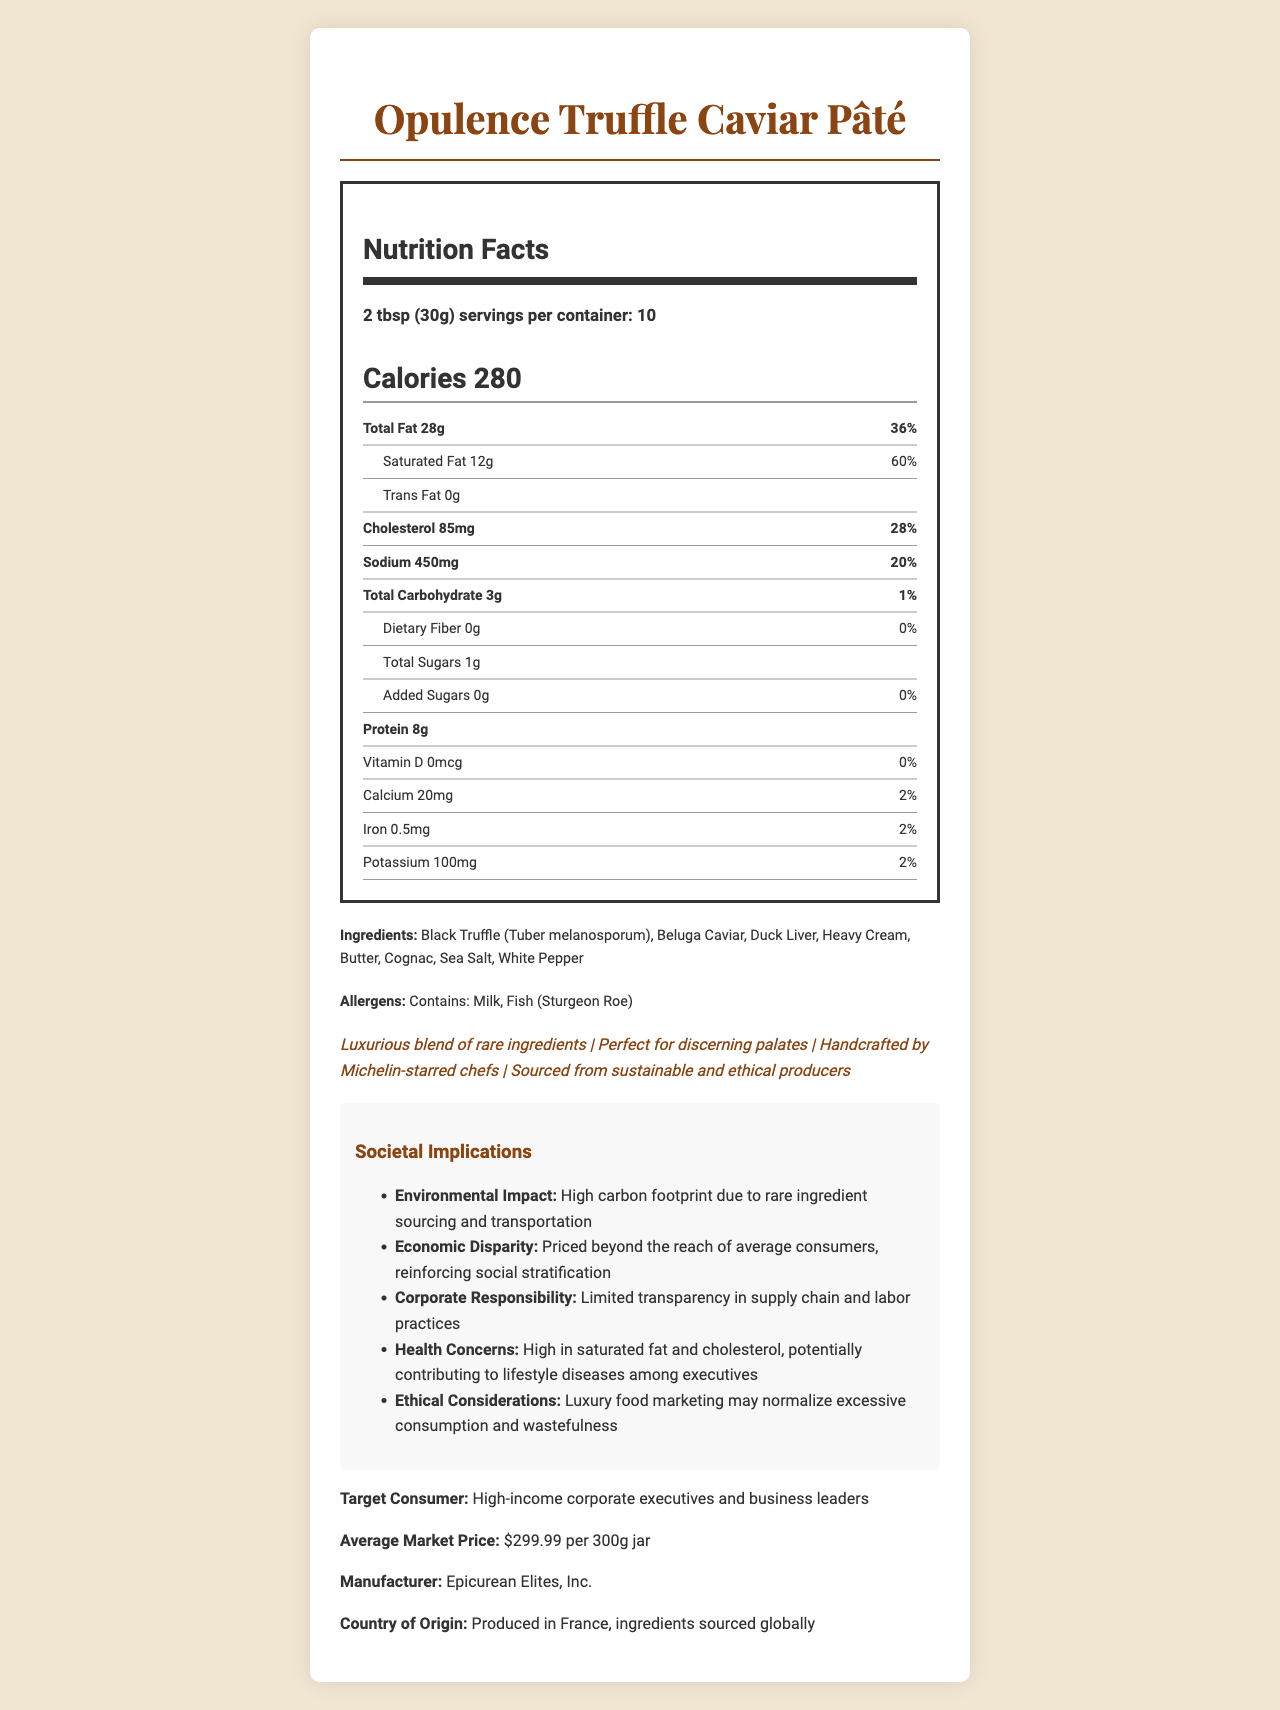What is the serving size of Opulence Truffle Caviar Pâté? The serving size is clearly mentioned as 2 tablespoons or 30 grams.
Answer: 2 tbsp (30g) How many calories are in one serving? The calories per serving are indicated as 280 on the Nutrition Facts label.
Answer: 280 What is the total amount of fat in one serving and its daily value percentage? The total fat content for one serving is shown as 28g, which is 36% of the daily value.
Answer: 28g, 36% What percentage of daily value for saturated fat does this product provide? The daily value percentage for saturated fat is listed as 60%.
Answer: 60% Does the product contain any trans fat? The label states that the trans fat content is 0g, meaning it contains no trans fat.
Answer: No How much cholesterol is in a single serving? The amount of cholesterol per serving is noted as 85mg.
Answer: 85mg What are two main allergens present in this product? The allergens indicated in the document are Milk and Fish (Sturgeon Roe).
Answer: Milk, Fish (Sturgeon Roe) Which of the following ingredients is NOT present in the Opulence Truffle Caviar Pâté? A. Black Truffle B. Duck Liver C. Olive Oil D. Heavy Cream Olive Oil is not listed among the ingredients in the document.
Answer: C. Olive Oil How many servings are there in a container of this product? A. 5 B. 10 C. 15 D. 20 The document specifies that there are 10 servings per container.
Answer: B. 10 Is the product manufactured in the United States? The product is produced in France, as indicated by the document.
Answer: No Summarize the main nutritional concerns associated with the Opulence Truffle Caviar Pâté. The main nutritional concerns are the excessive calorie count (280 per serving), high total fat (28g), saturated fat (12g), and cholesterol (85mg) per serving.
Answer: High in calories, total fat, saturated fat, and cholesterol. What is the average market price of Opulence Truffle Caviar Pâté? The document specifies the average market price as $299.99 for a 300g jar.
Answer: $299.99 per 300g jar What types of consumers is this product targeted at? The target consumer section of the document mentions that it is aimed at high-income corporate executives and business leaders.
Answer: High-income corporate executives and business leaders What is the carbon footprint implication mentioned for this product? The societal implications section lists a high carbon footprint due to sourcing and transporting rare ingredients.
Answer: High carbon footprint due to rare ingredient sourcing and transportation Can the exact environmental impact of the product be determined solely from this document? The document mentions a high carbon footprint but does not provide specific data or metrics to quantify the impact.
Answer: No Analyze the ethical implications of marketing such a luxury food item. Ethical considerations include the normalization of excessive consumption and wastefulness, as well as concerns about transparency in supply chain and labor practices.
Answer: The marketing of luxury food items may normalize excessive consumption and wastefulness, and limited transparency in supply chain and labor practices raises ethical concerns. What is one claimed benefit of the product according to its marketing claims? Among the marketing claims, it is stated that the product is handcrafted by Michelin-starred chefs.
Answer: Handcrafted by Michelin-starred chefs Identify a claim related to the sustainability of the product. One of the marketing claims mentions that the product is sourced from sustainable and ethical producers.
Answer: Sourced from sustainable and ethical producers Does the product contain any added sugars? The document lists 0g of added sugars, indicating there are none present in the product.
Answer: No Which of the following is listed as a societal implication? A. Increase in local employment B. Reduction in carbon footprint C. Reinforcing social stratification D. Improved nutritional quality The societal implications section mentions that the product is priced beyond the reach of average consumers, thus reinforcing social stratification.
Answer: C. Reinforcing social stratification 